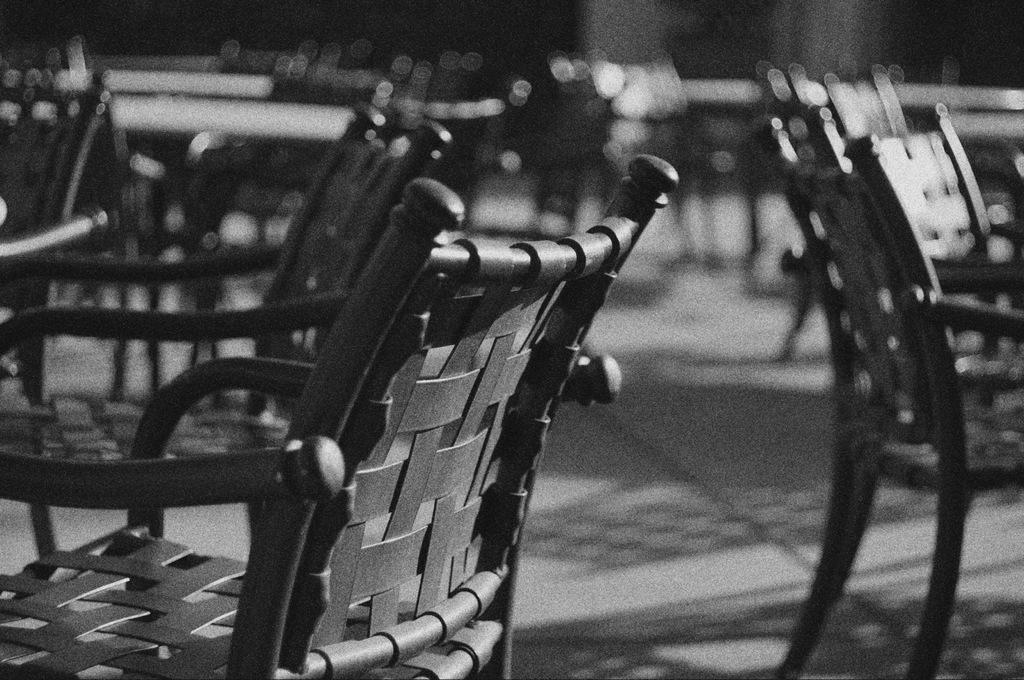Please provide a concise description of this image. It is a black and white image. In this image we can see the chairs. We can also see the path. 